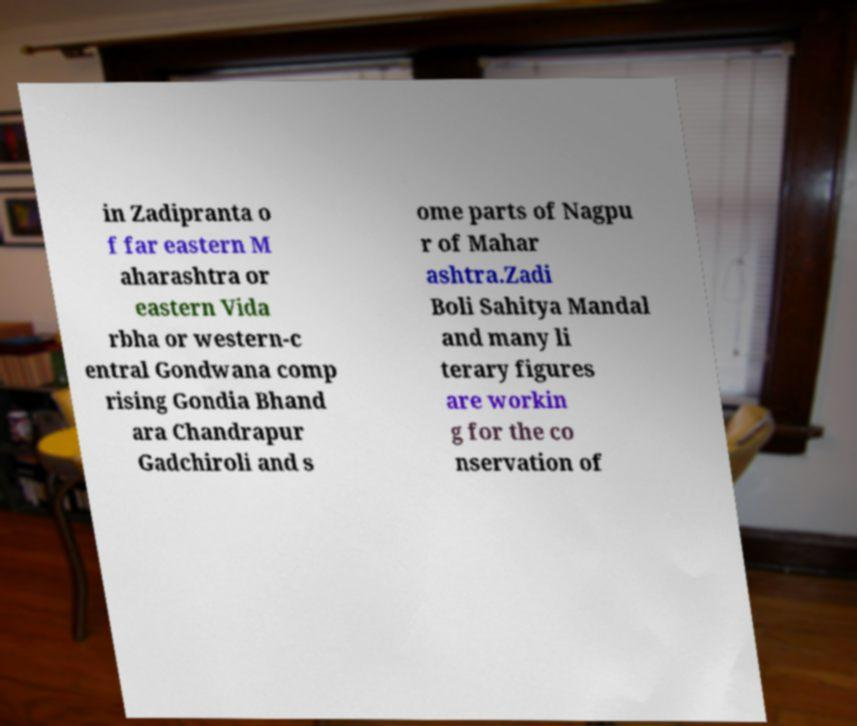What messages or text are displayed in this image? I need them in a readable, typed format. in Zadipranta o f far eastern M aharashtra or eastern Vida rbha or western-c entral Gondwana comp rising Gondia Bhand ara Chandrapur Gadchiroli and s ome parts of Nagpu r of Mahar ashtra.Zadi Boli Sahitya Mandal and many li terary figures are workin g for the co nservation of 